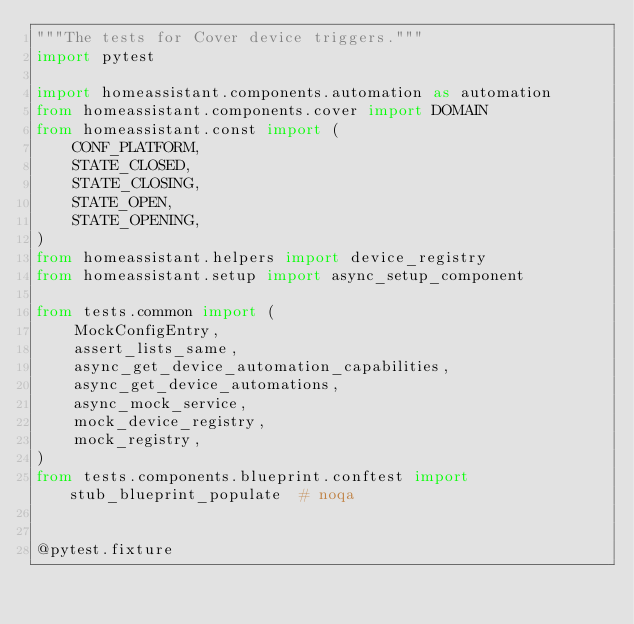<code> <loc_0><loc_0><loc_500><loc_500><_Python_>"""The tests for Cover device triggers."""
import pytest

import homeassistant.components.automation as automation
from homeassistant.components.cover import DOMAIN
from homeassistant.const import (
    CONF_PLATFORM,
    STATE_CLOSED,
    STATE_CLOSING,
    STATE_OPEN,
    STATE_OPENING,
)
from homeassistant.helpers import device_registry
from homeassistant.setup import async_setup_component

from tests.common import (
    MockConfigEntry,
    assert_lists_same,
    async_get_device_automation_capabilities,
    async_get_device_automations,
    async_mock_service,
    mock_device_registry,
    mock_registry,
)
from tests.components.blueprint.conftest import stub_blueprint_populate  # noqa


@pytest.fixture</code> 